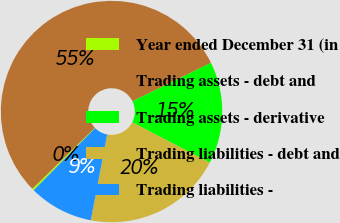<chart> <loc_0><loc_0><loc_500><loc_500><pie_chart><fcel>Year ended December 31 (in<fcel>Trading assets - debt and<fcel>Trading assets - derivative<fcel>Trading liabilities - debt and<fcel>Trading liabilities -<nl><fcel>0.29%<fcel>55.05%<fcel>14.89%<fcel>20.36%<fcel>9.41%<nl></chart> 